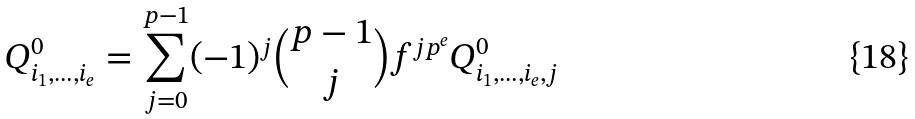<formula> <loc_0><loc_0><loc_500><loc_500>Q _ { i _ { 1 } , \dots , i _ { e } } ^ { 0 } = \sum _ { j = 0 } ^ { p - 1 } ( - 1 ) ^ { j } { { p - 1 } \choose { j } } f ^ { j p ^ { e } } Q _ { i _ { 1 } , \dots , i _ { e } , j } ^ { 0 }</formula> 